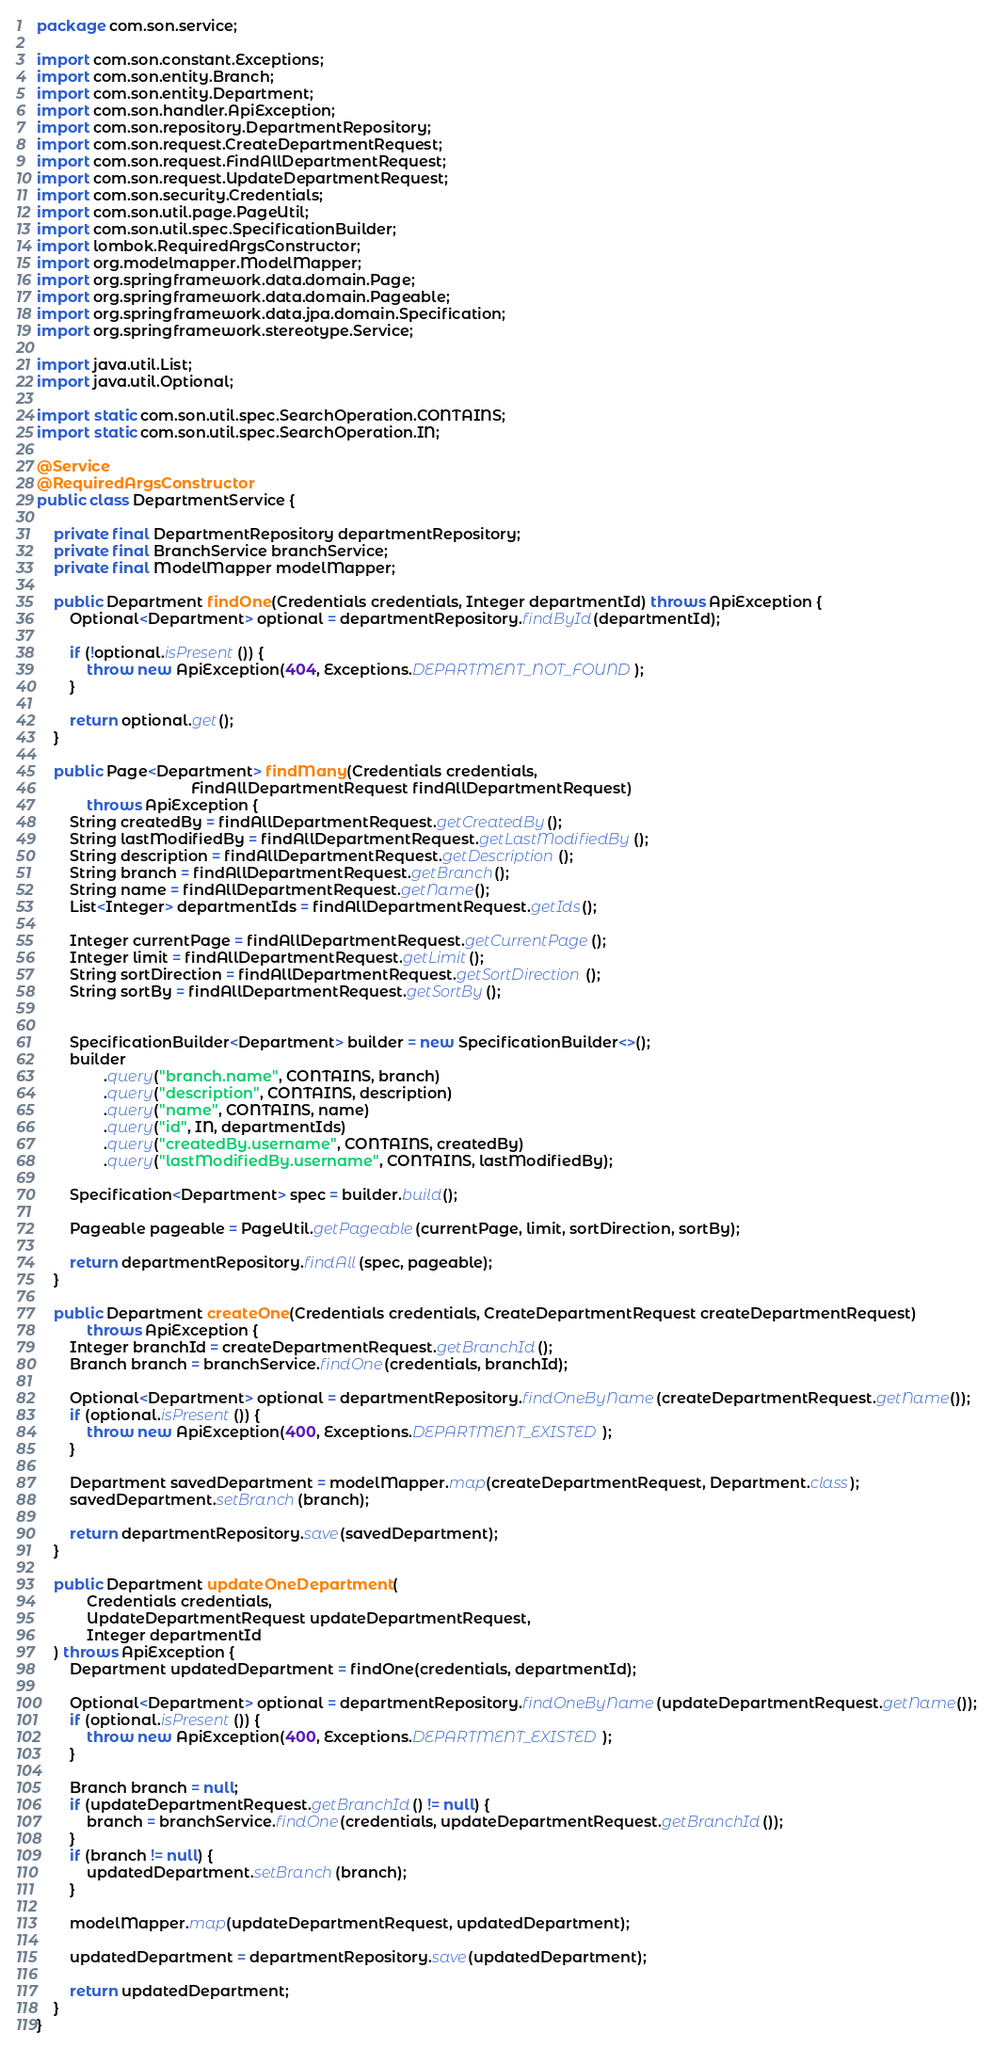Convert code to text. <code><loc_0><loc_0><loc_500><loc_500><_Java_>package com.son.service;

import com.son.constant.Exceptions;
import com.son.entity.Branch;
import com.son.entity.Department;
import com.son.handler.ApiException;
import com.son.repository.DepartmentRepository;
import com.son.request.CreateDepartmentRequest;
import com.son.request.FindAllDepartmentRequest;
import com.son.request.UpdateDepartmentRequest;
import com.son.security.Credentials;
import com.son.util.page.PageUtil;
import com.son.util.spec.SpecificationBuilder;
import lombok.RequiredArgsConstructor;
import org.modelmapper.ModelMapper;
import org.springframework.data.domain.Page;
import org.springframework.data.domain.Pageable;
import org.springframework.data.jpa.domain.Specification;
import org.springframework.stereotype.Service;

import java.util.List;
import java.util.Optional;

import static com.son.util.spec.SearchOperation.CONTAINS;
import static com.son.util.spec.SearchOperation.IN;

@Service
@RequiredArgsConstructor
public class DepartmentService {

    private final DepartmentRepository departmentRepository;
    private final BranchService branchService;
    private final ModelMapper modelMapper;

    public Department findOne(Credentials credentials, Integer departmentId) throws ApiException {
        Optional<Department> optional = departmentRepository.findById(departmentId);

        if (!optional.isPresent()) {
            throw new ApiException(404, Exceptions.DEPARTMENT_NOT_FOUND);
        }

        return optional.get();
    }

    public Page<Department> findMany(Credentials credentials,
                                     FindAllDepartmentRequest findAllDepartmentRequest)
            throws ApiException {
        String createdBy = findAllDepartmentRequest.getCreatedBy();
        String lastModifiedBy = findAllDepartmentRequest.getLastModifiedBy();
        String description = findAllDepartmentRequest.getDescription();
        String branch = findAllDepartmentRequest.getBranch();
        String name = findAllDepartmentRequest.getName();
        List<Integer> departmentIds = findAllDepartmentRequest.getIds();

        Integer currentPage = findAllDepartmentRequest.getCurrentPage();
        Integer limit = findAllDepartmentRequest.getLimit();
        String sortDirection = findAllDepartmentRequest.getSortDirection();
        String sortBy = findAllDepartmentRequest.getSortBy();


        SpecificationBuilder<Department> builder = new SpecificationBuilder<>();
        builder
                .query("branch.name", CONTAINS, branch)
                .query("description", CONTAINS, description)
                .query("name", CONTAINS, name)
                .query("id", IN, departmentIds)
                .query("createdBy.username", CONTAINS, createdBy)
                .query("lastModifiedBy.username", CONTAINS, lastModifiedBy);

        Specification<Department> spec = builder.build();

        Pageable pageable = PageUtil.getPageable(currentPage, limit, sortDirection, sortBy);

        return departmentRepository.findAll(spec, pageable);
    }

    public Department createOne(Credentials credentials, CreateDepartmentRequest createDepartmentRequest)
            throws ApiException {
        Integer branchId = createDepartmentRequest.getBranchId();
        Branch branch = branchService.findOne(credentials, branchId);

        Optional<Department> optional = departmentRepository.findOneByName(createDepartmentRequest.getName());
        if (optional.isPresent()) {
            throw new ApiException(400, Exceptions.DEPARTMENT_EXISTED);
        }

        Department savedDepartment = modelMapper.map(createDepartmentRequest, Department.class);
        savedDepartment.setBranch(branch);

        return departmentRepository.save(savedDepartment);
    }

    public Department updateOneDepartment(
            Credentials credentials,
            UpdateDepartmentRequest updateDepartmentRequest,
            Integer departmentId
    ) throws ApiException {
        Department updatedDepartment = findOne(credentials, departmentId);

        Optional<Department> optional = departmentRepository.findOneByName(updateDepartmentRequest.getName());
        if (optional.isPresent()) {
            throw new ApiException(400, Exceptions.DEPARTMENT_EXISTED);
        }

        Branch branch = null;
        if (updateDepartmentRequest.getBranchId() != null) {
            branch = branchService.findOne(credentials, updateDepartmentRequest.getBranchId());
        }
        if (branch != null) {
            updatedDepartment.setBranch(branch);
        }

        modelMapper.map(updateDepartmentRequest, updatedDepartment);

        updatedDepartment = departmentRepository.save(updatedDepartment);

        return updatedDepartment;
    }
}
</code> 